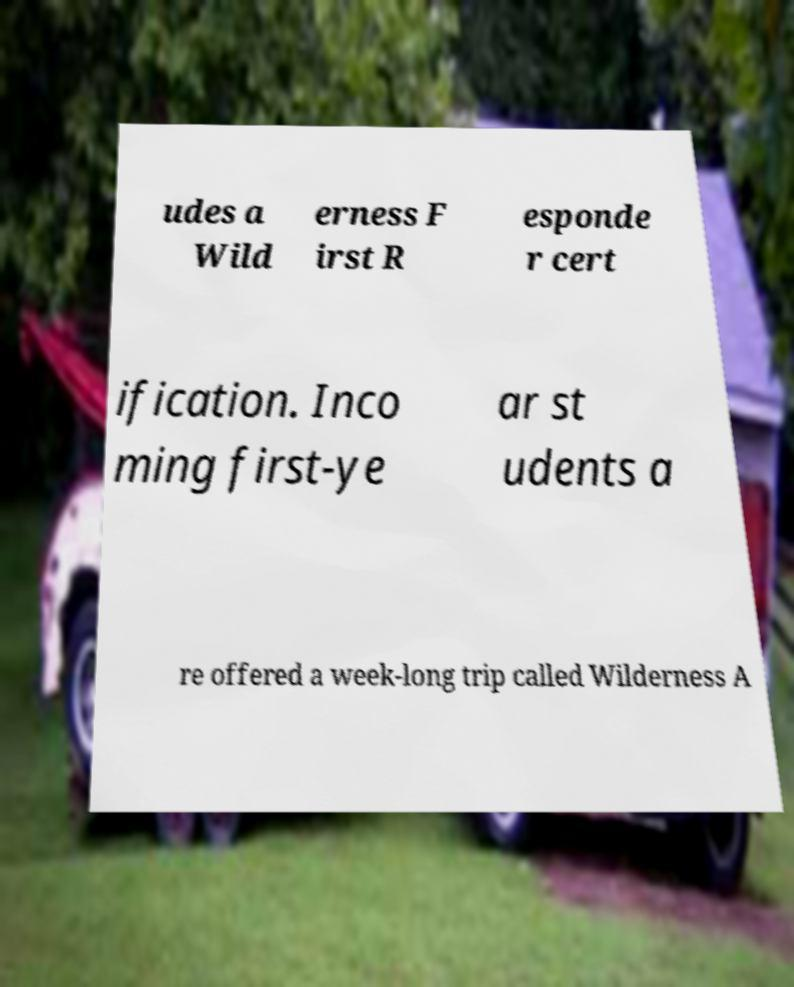Please read and relay the text visible in this image. What does it say? udes a Wild erness F irst R esponde r cert ification. Inco ming first-ye ar st udents a re offered a week-long trip called Wilderness A 